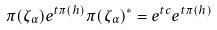<formula> <loc_0><loc_0><loc_500><loc_500>\pi ( \zeta _ { \alpha } ) e ^ { t \pi ( h ) } \pi ( \zeta _ { \alpha } ) ^ { * } = e ^ { t c } e ^ { t \pi ( h ) }</formula> 